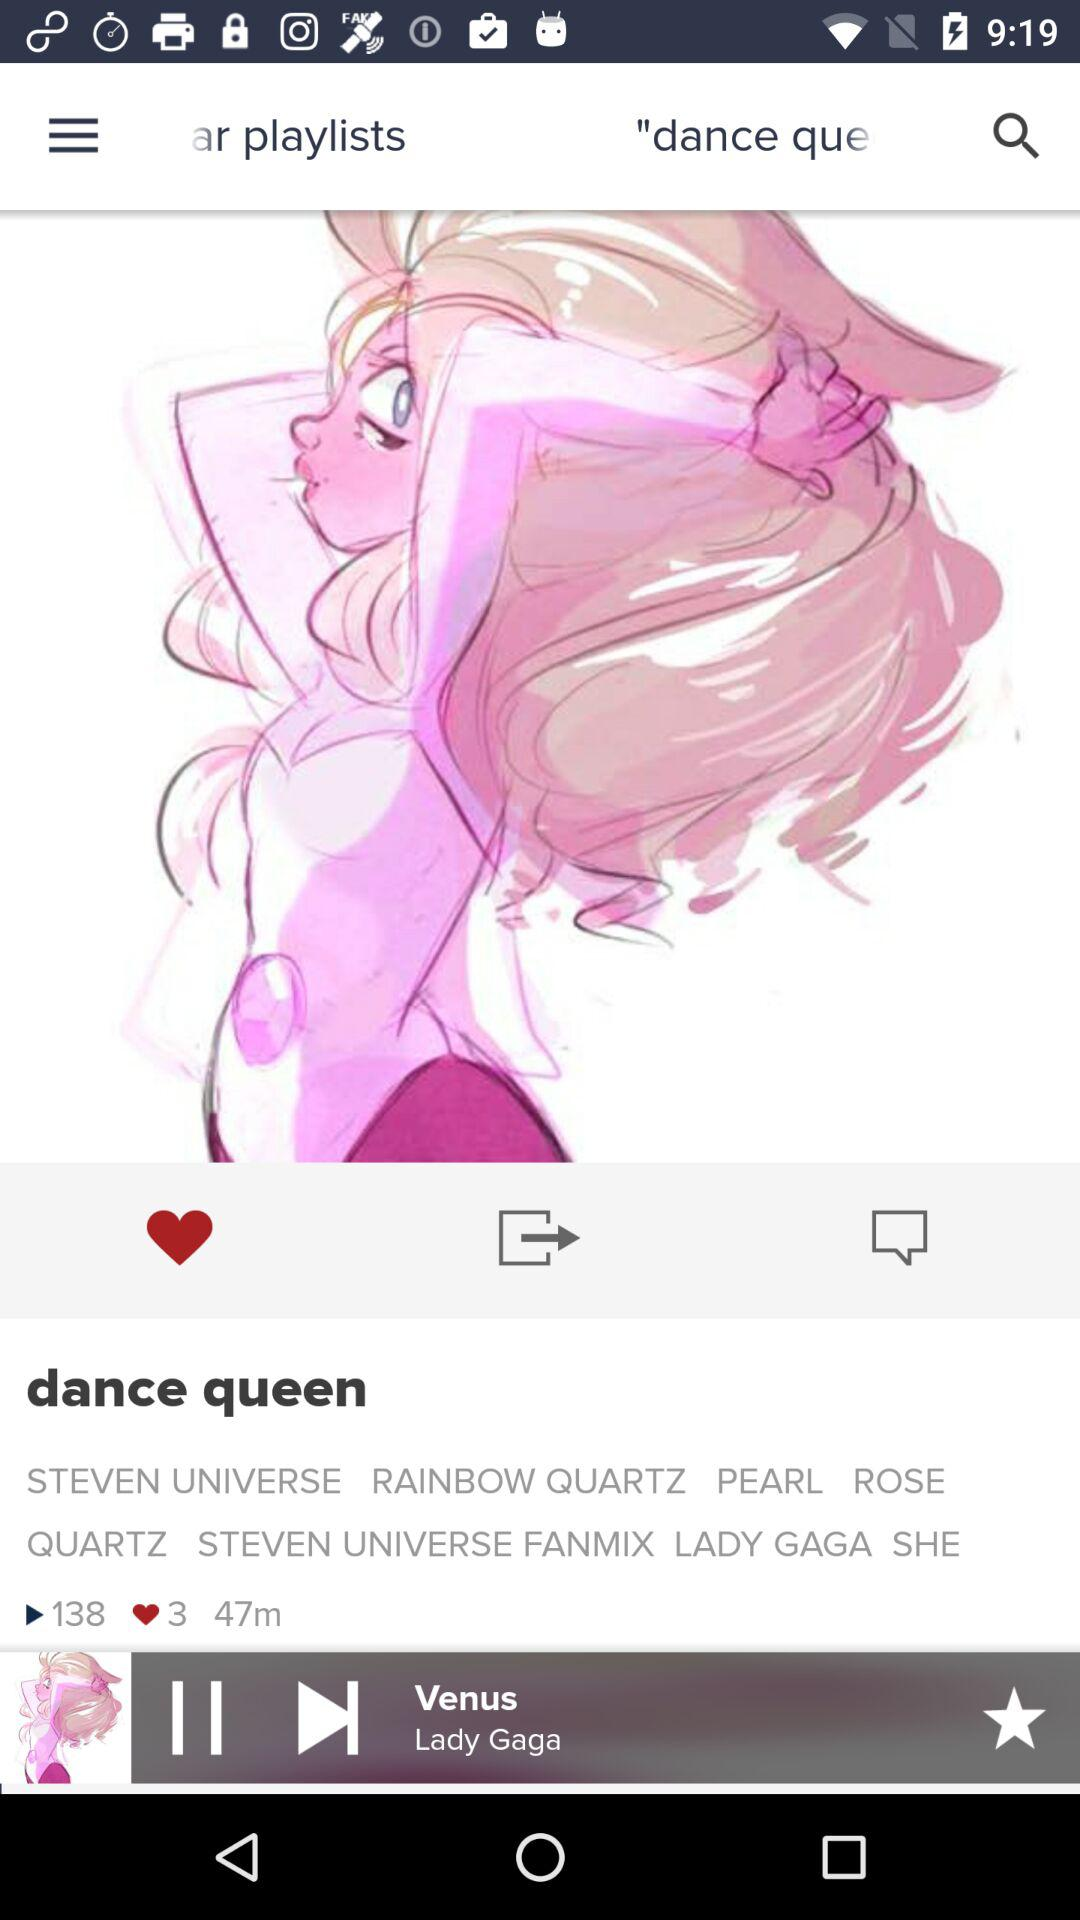What is the name of the playlist? The name of the playlist is "dance queen". 